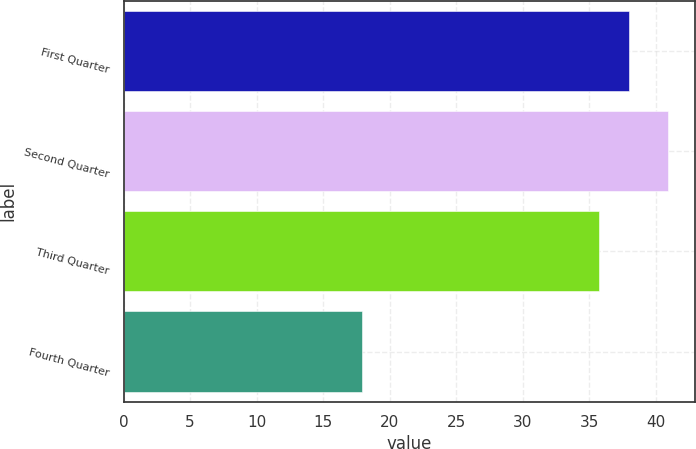<chart> <loc_0><loc_0><loc_500><loc_500><bar_chart><fcel>First Quarter<fcel>Second Quarter<fcel>Third Quarter<fcel>Fourth Quarter<nl><fcel>38.02<fcel>40.9<fcel>35.72<fcel>17.95<nl></chart> 